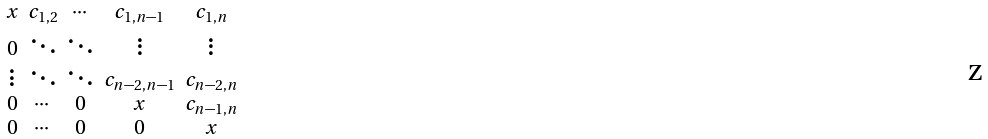<formula> <loc_0><loc_0><loc_500><loc_500>\begin{smallmatrix} x & c _ { 1 , 2 } & \cdots & c _ { 1 , n - 1 } & c _ { 1 , n } \\ 0 & \ddots & \ddots & \vdots & \vdots \\ \vdots & \ddots & \ddots & c _ { n - 2 , n - 1 } & c _ { n - 2 , n } \\ 0 & \cdots & 0 & x & c _ { n - 1 , n } \\ 0 & \cdots & 0 & 0 & x \end{smallmatrix}</formula> 